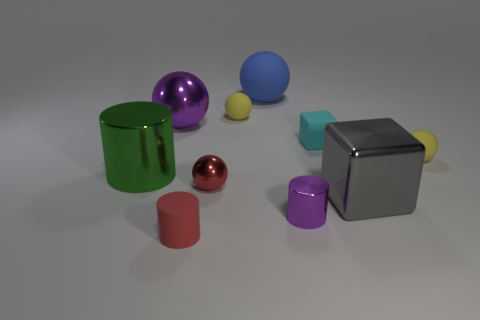Subtract all red spheres. How many spheres are left? 4 Subtract all large blue balls. How many balls are left? 4 Subtract all brown spheres. Subtract all yellow cylinders. How many spheres are left? 5 Subtract all blocks. How many objects are left? 8 Add 1 green shiny objects. How many green shiny objects are left? 2 Add 5 gray metallic blocks. How many gray metallic blocks exist? 6 Subtract 1 cyan blocks. How many objects are left? 9 Subtract all big gray cubes. Subtract all cylinders. How many objects are left? 6 